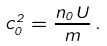Convert formula to latex. <formula><loc_0><loc_0><loc_500><loc_500>c _ { 0 } ^ { 2 } = \frac { n _ { 0 } U } { m } \, .</formula> 